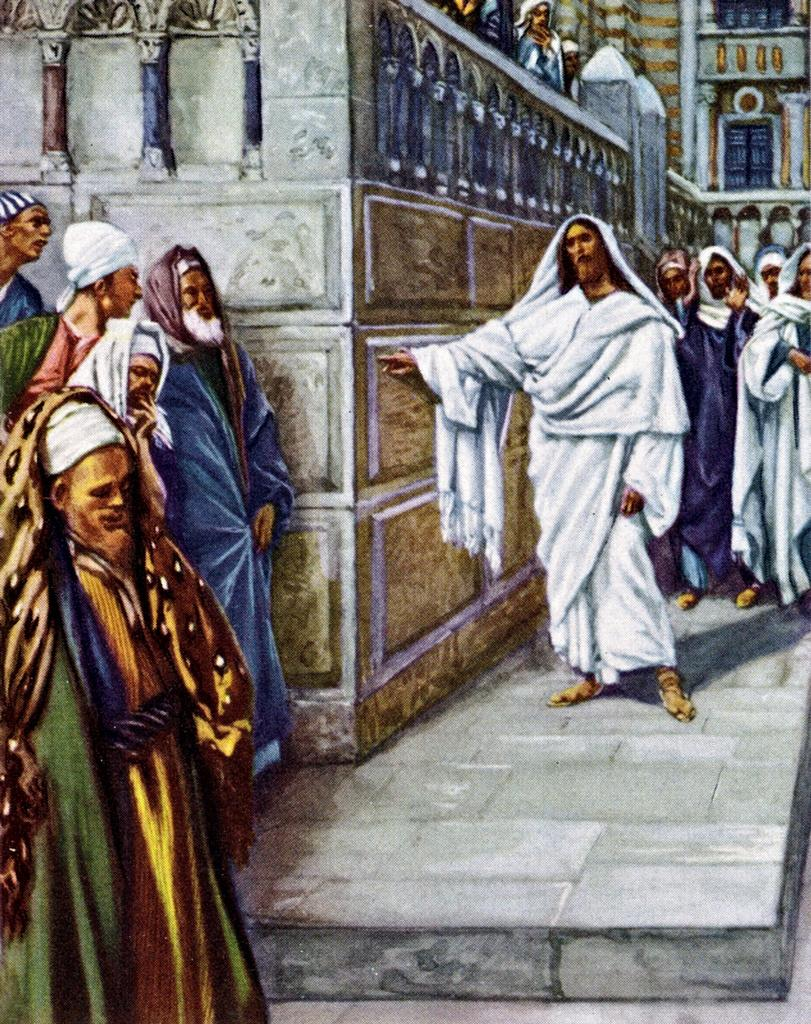What is the main subject of the image? The main subject of the image is a group of people. Where are the people located in the image? The people are standing on the floor. What can be seen in the background of the image? There is a building in the background of the image. What specific feature of the building is mentioned? The building has windows. Are there any other people visible in the image besides the group? Yes, there are people visible in the background of the image. What type of metal is the toy cow made of in the image? There is no toy cow present in the image, so it is not possible to determine the type of metal it might be made of. 